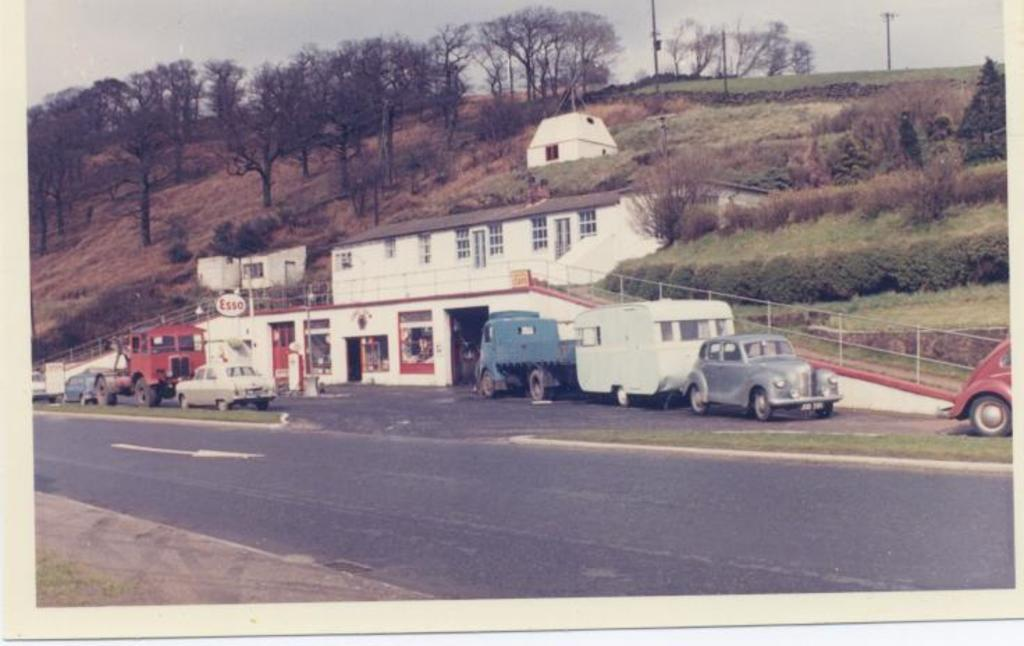What is the main subject of the photo in the image? The main subject of the photo is vehicles on the road. What can be seen behind the vehicles in the image? There is a building behind the vehicles in the image. What type of cooking equipment is present in the image? Iron griddles are present in the image. What type of infrastructure is visible in the image? Electric poles are visible in the image. What type of vegetation is present in the image? Trees are present in the image. What is visible in the background of the image? The sky is visible in the image. How many lawyers are visible in the image? There are no lawyers present in the image. What type of thread is being used to sew the vehicles together in the image? There is no thread or sewing activity present in the image; the vehicles are not connected in any way. 